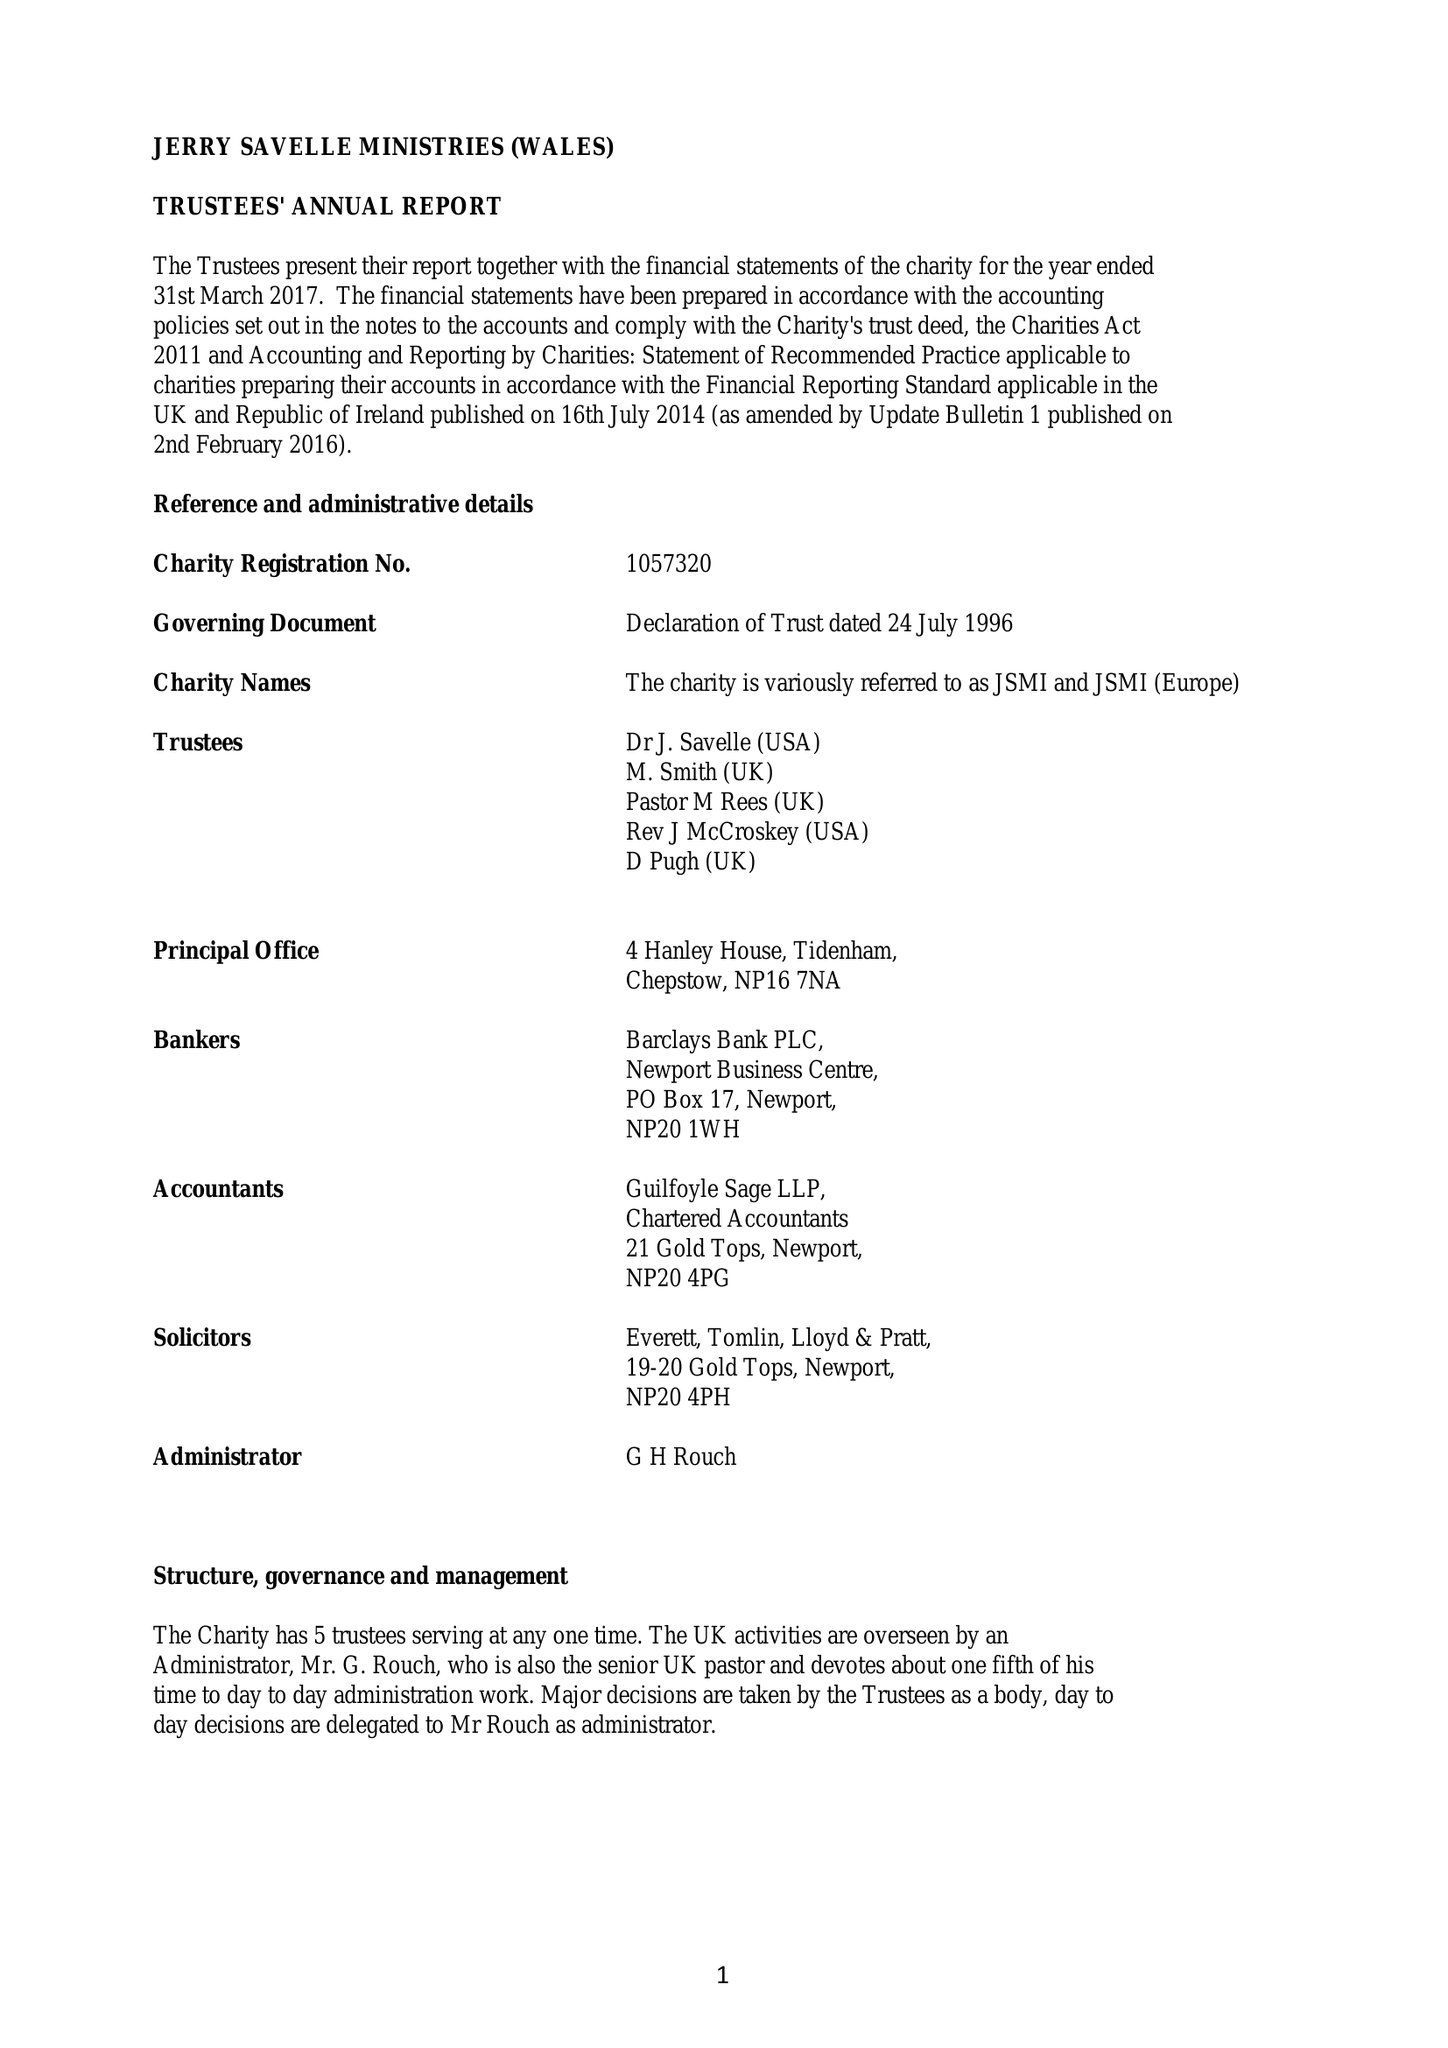What is the value for the spending_annually_in_british_pounds?
Answer the question using a single word or phrase. 217318.00 